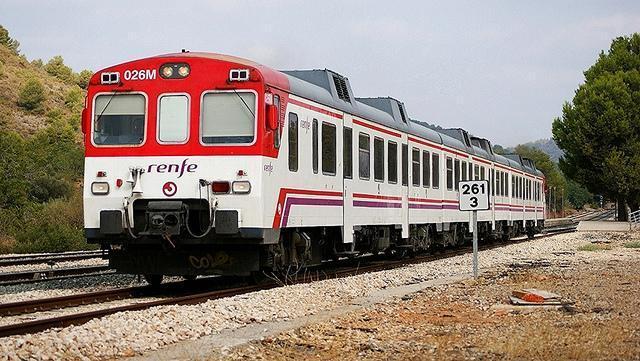How many cows are in the photo?
Give a very brief answer. 0. 